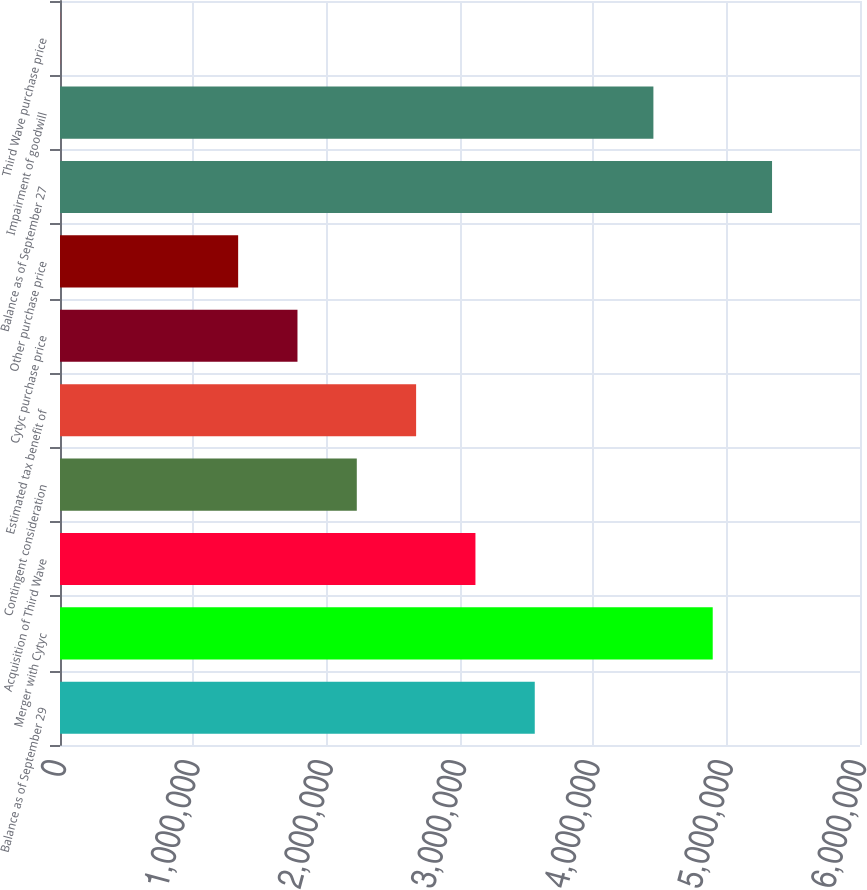<chart> <loc_0><loc_0><loc_500><loc_500><bar_chart><fcel>Balance as of September 29<fcel>Merger with Cytyc<fcel>Acquisition of Third Wave<fcel>Contingent consideration<fcel>Estimated tax benefit of<fcel>Cytyc purchase price<fcel>Other purchase price<fcel>Balance as of September 27<fcel>Impairment of goodwill<fcel>Third Wave purchase price<nl><fcel>3.56069e+06<fcel>4.8954e+06<fcel>3.11578e+06<fcel>2.22597e+06<fcel>2.67088e+06<fcel>1.78107e+06<fcel>1.33616e+06<fcel>5.34031e+06<fcel>4.4505e+06<fcel>1450<nl></chart> 